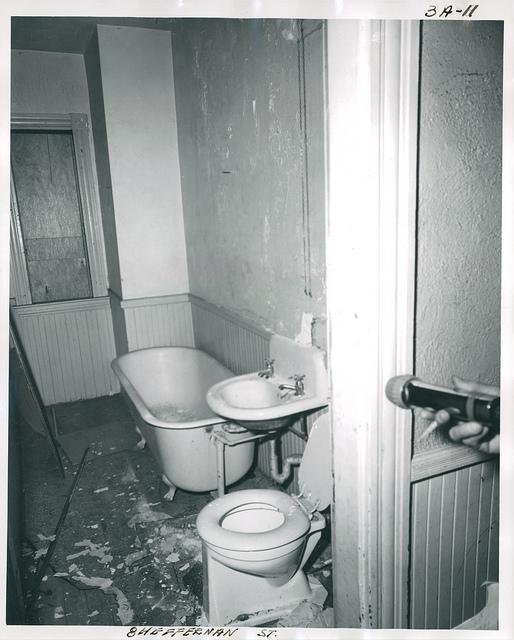Is the toilet clean?
Answer briefly. Yes. Is this a modern bathroom?
Quick response, please. No. What is in the person's hand?
Quick response, please. Flashlight. 